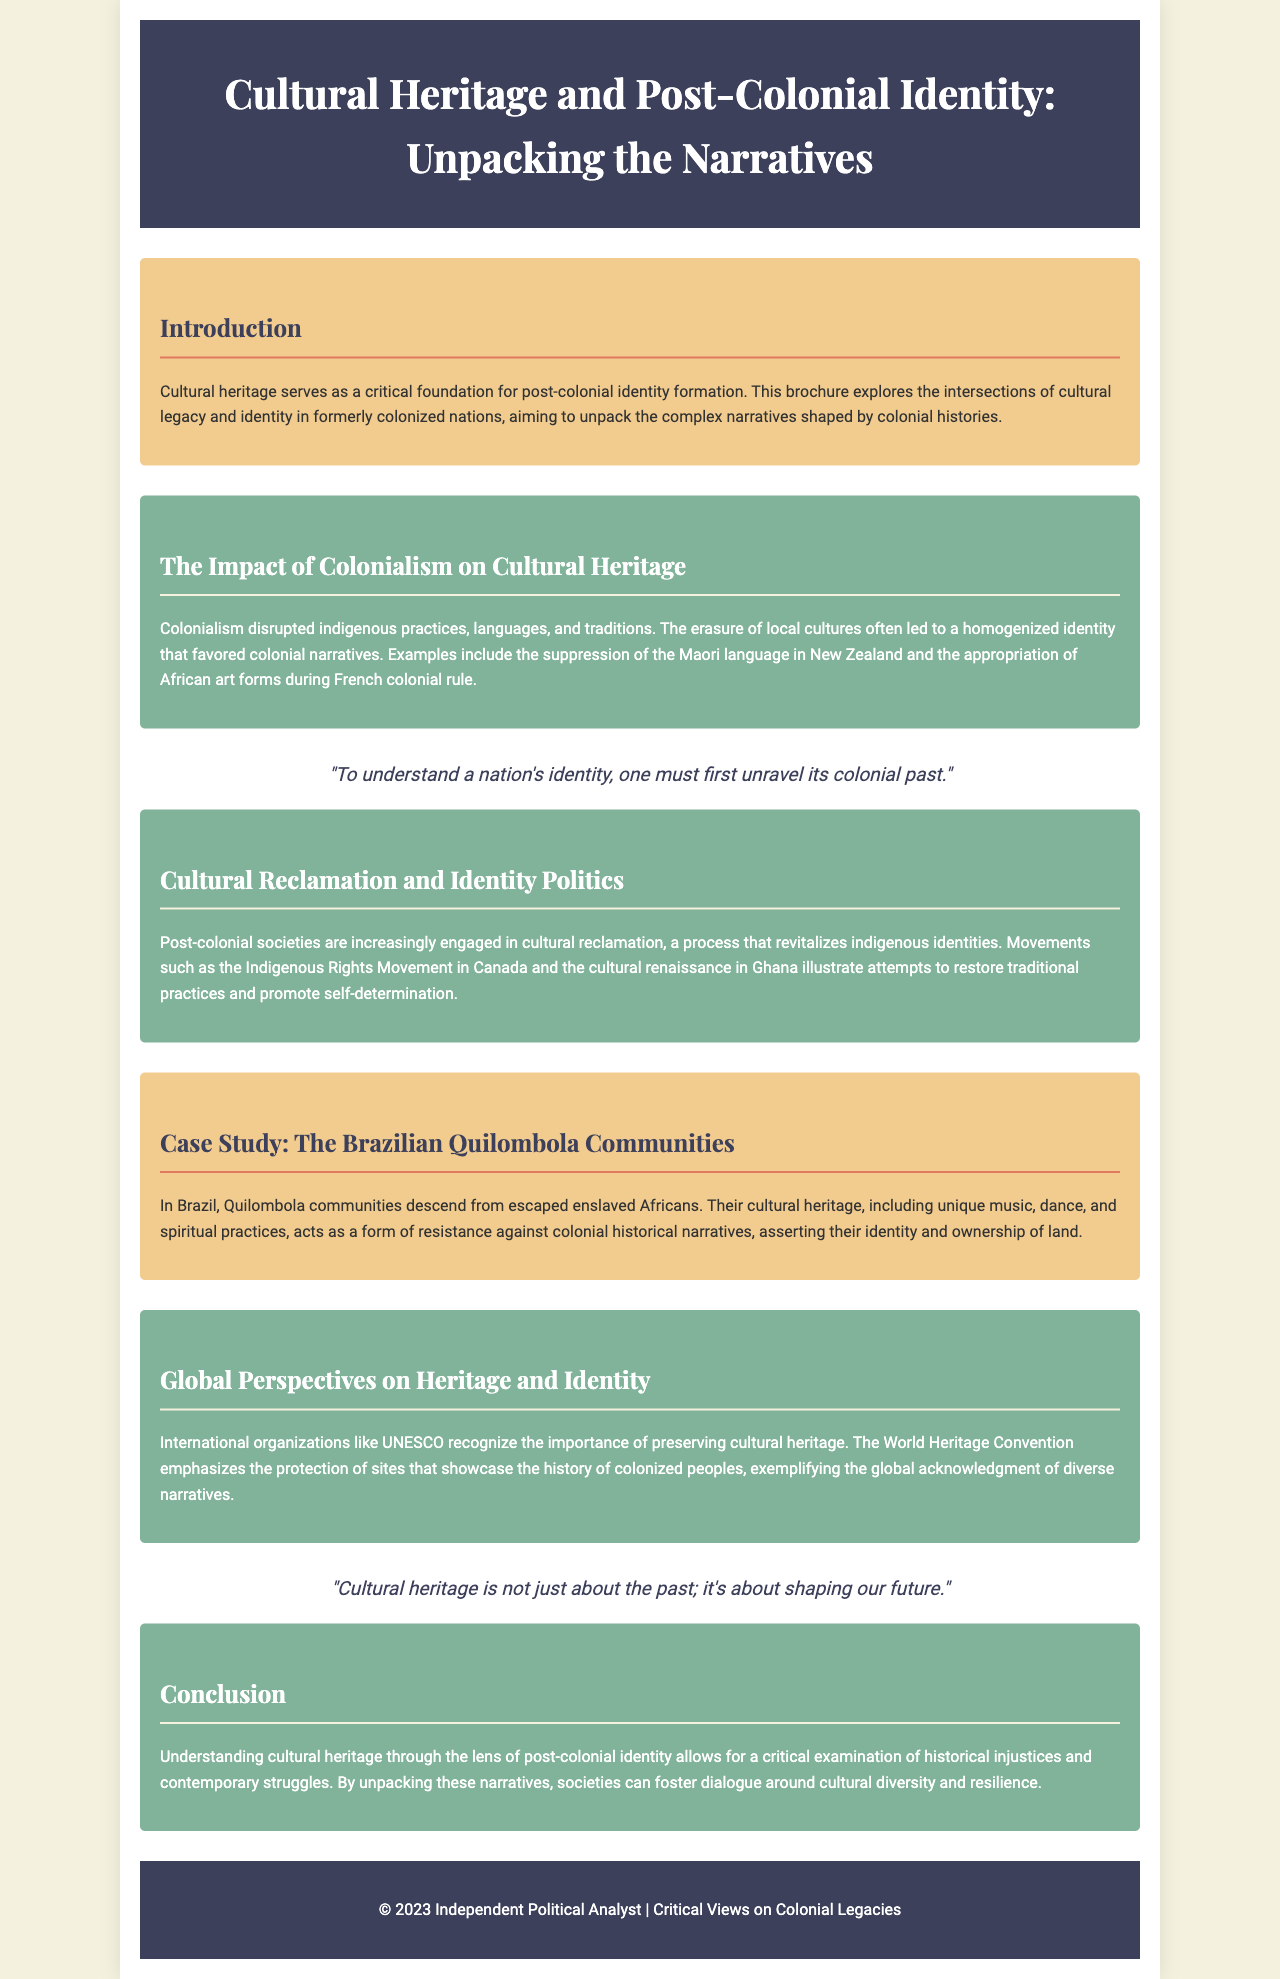What is the title of the brochure? The title is stated in the header of the document as the main subject being explored.
Answer: Cultural Heritage and Post-Colonial Identity: Unpacking the Narratives Who are the communities highlighted in the case study? The case study section mentions specific communities as an example of cultural heritage in relation to post-colonial identity.
Answer: Quilombola communities What movement is mentioned in the brochure related to cultural reclamation in Canada? The document specifically identifies a movement focused on indigenous rights within Canada.
Answer: Indigenous Rights Movement Which international organization is mentioned as recognizing the importance of preserving cultural heritage? The document references this organization in the context of global efforts towards heritage preservation.
Answer: UNESCO What is one of the impacts of colonialism mentioned in the second section? This question seeks a specific effect discussed in relation to cultural heritage due to colonial actions.
Answer: Disrupted indigenous practices What does cultural heritage shape according to the quote in the brochure? The quote implies a broader significance of cultural heritage beyond historical context, specifically in relation to future implications.
Answer: Our future How many sections are there in the main content of the brochure? The question looks for a count of the distinct informational parts that cover various themes within the document.
Answer: Six sections 